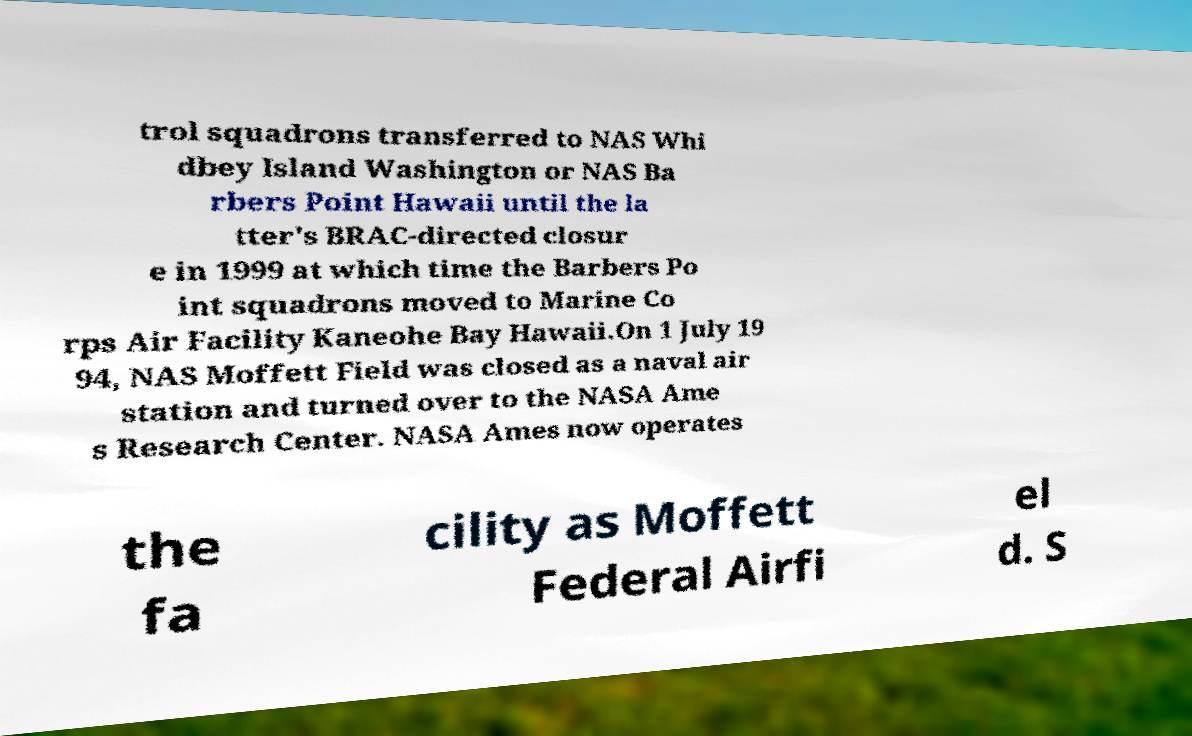Could you extract and type out the text from this image? trol squadrons transferred to NAS Whi dbey Island Washington or NAS Ba rbers Point Hawaii until the la tter's BRAC-directed closur e in 1999 at which time the Barbers Po int squadrons moved to Marine Co rps Air Facility Kaneohe Bay Hawaii.On 1 July 19 94, NAS Moffett Field was closed as a naval air station and turned over to the NASA Ame s Research Center. NASA Ames now operates the fa cility as Moffett Federal Airfi el d. S 